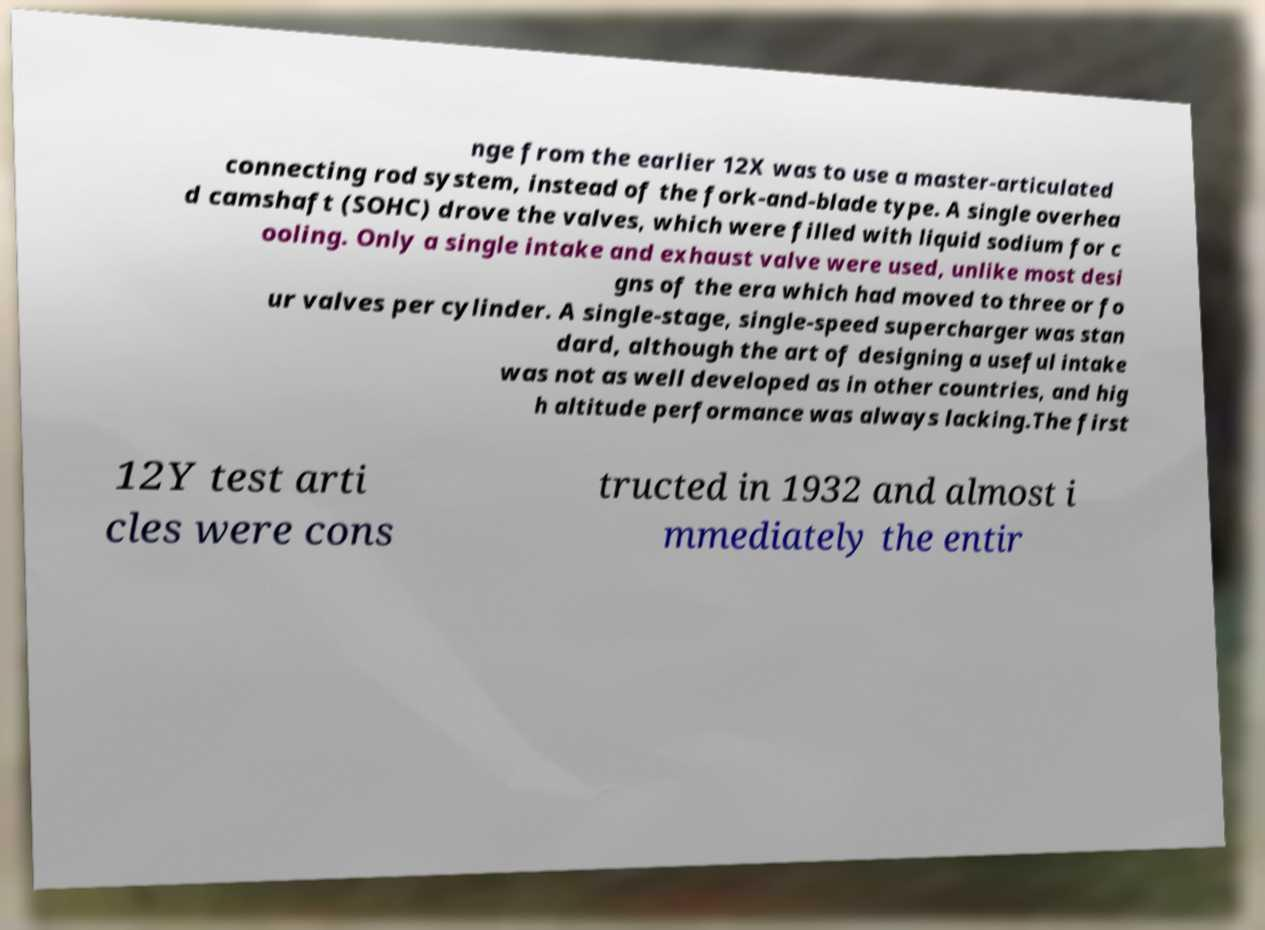For documentation purposes, I need the text within this image transcribed. Could you provide that? nge from the earlier 12X was to use a master-articulated connecting rod system, instead of the fork-and-blade type. A single overhea d camshaft (SOHC) drove the valves, which were filled with liquid sodium for c ooling. Only a single intake and exhaust valve were used, unlike most desi gns of the era which had moved to three or fo ur valves per cylinder. A single-stage, single-speed supercharger was stan dard, although the art of designing a useful intake was not as well developed as in other countries, and hig h altitude performance was always lacking.The first 12Y test arti cles were cons tructed in 1932 and almost i mmediately the entir 